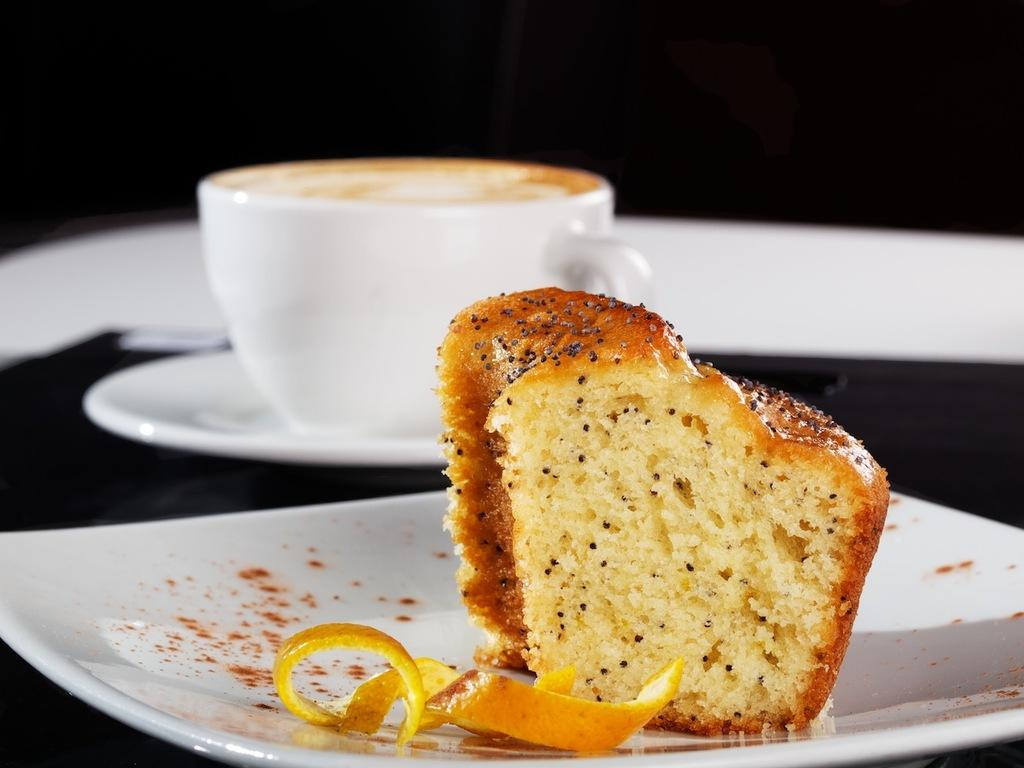What is located at the bottom of the image? There is a white plate at the bottom of the image. What is on the white plate? There is a piece of cake on the white plate. What other dish is visible in the image? There is a white cup with a saucer behind the plate. How would you describe the overall color scheme of the image? The background of the image is black and white. What type of education does the brush in the image have? There is no brush present in the image, so it is not possible to determine its level of education. 